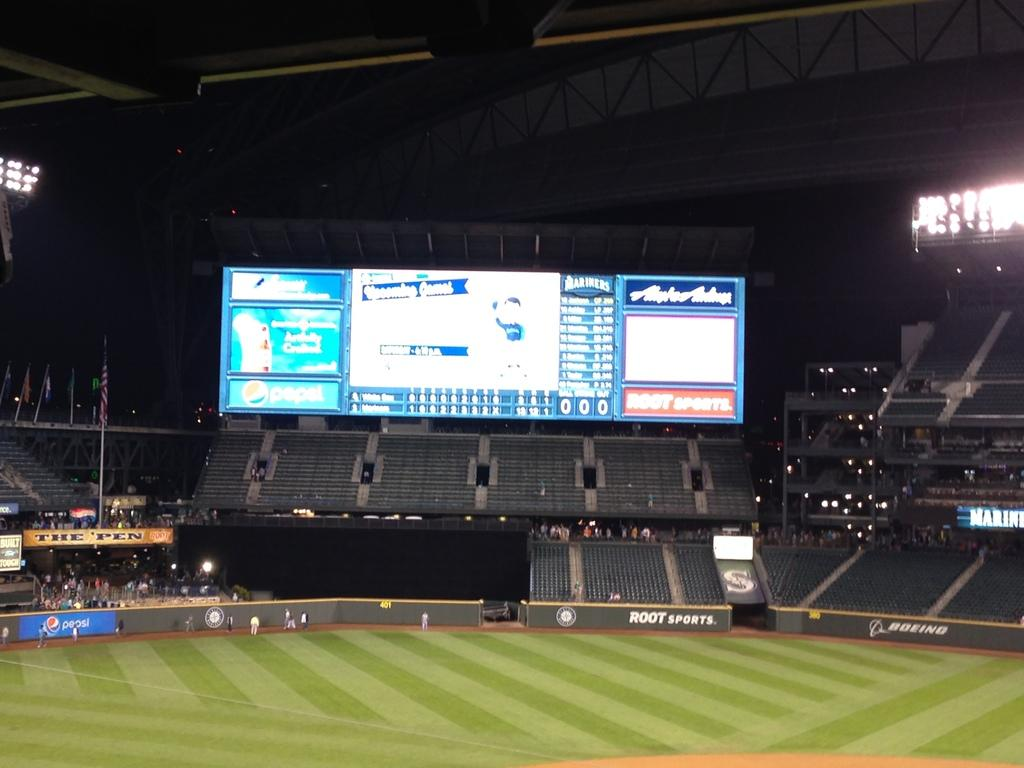<image>
Give a short and clear explanation of the subsequent image. A large display at a baseball arena has a logo for Root Sports in the bottom right corner. 